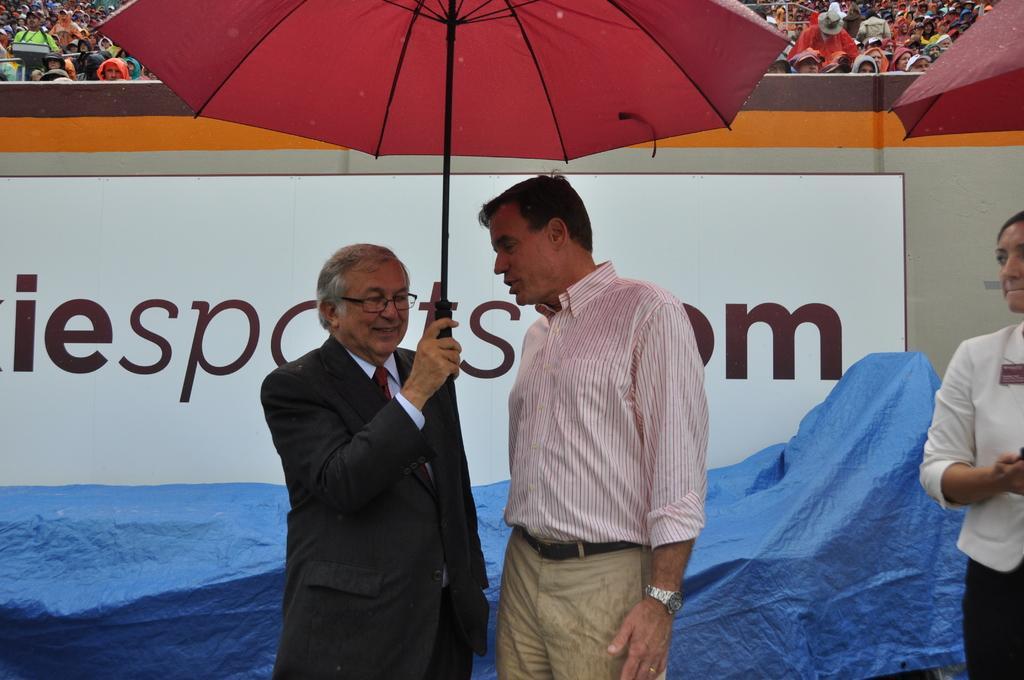In one or two sentences, can you explain what this image depicts? In this picture I can see three persons standing, in which two persons are holding umbrellas. I can see a tarpaulin, board, and in the background there are group of people. 